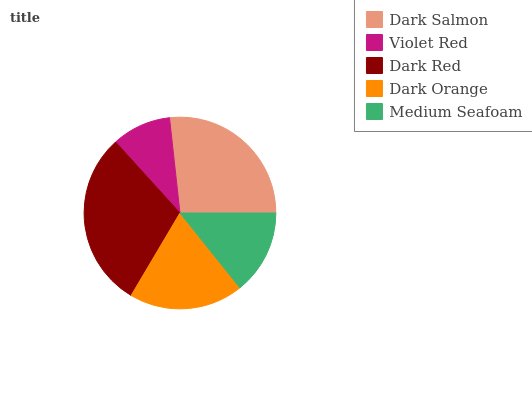Is Violet Red the minimum?
Answer yes or no. Yes. Is Dark Red the maximum?
Answer yes or no. Yes. Is Dark Red the minimum?
Answer yes or no. No. Is Violet Red the maximum?
Answer yes or no. No. Is Dark Red greater than Violet Red?
Answer yes or no. Yes. Is Violet Red less than Dark Red?
Answer yes or no. Yes. Is Violet Red greater than Dark Red?
Answer yes or no. No. Is Dark Red less than Violet Red?
Answer yes or no. No. Is Dark Orange the high median?
Answer yes or no. Yes. Is Dark Orange the low median?
Answer yes or no. Yes. Is Dark Red the high median?
Answer yes or no. No. Is Dark Red the low median?
Answer yes or no. No. 